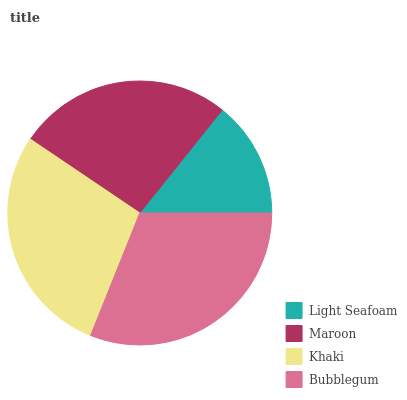Is Light Seafoam the minimum?
Answer yes or no. Yes. Is Bubblegum the maximum?
Answer yes or no. Yes. Is Maroon the minimum?
Answer yes or no. No. Is Maroon the maximum?
Answer yes or no. No. Is Maroon greater than Light Seafoam?
Answer yes or no. Yes. Is Light Seafoam less than Maroon?
Answer yes or no. Yes. Is Light Seafoam greater than Maroon?
Answer yes or no. No. Is Maroon less than Light Seafoam?
Answer yes or no. No. Is Khaki the high median?
Answer yes or no. Yes. Is Maroon the low median?
Answer yes or no. Yes. Is Bubblegum the high median?
Answer yes or no. No. Is Khaki the low median?
Answer yes or no. No. 